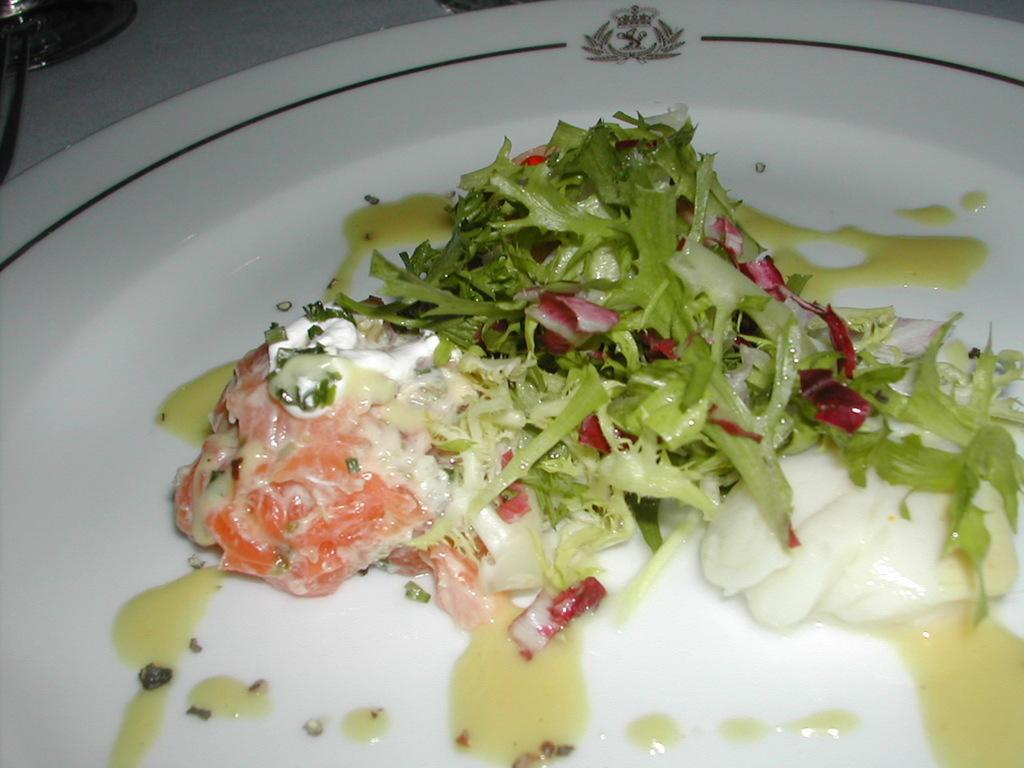What is present on the plate in the image? There is a food item on the plate. Can you describe the food item on the plate? There is a salad on the plate. What type of porter is serving the salad in the image? There is no porter present in the image, and the salad is not being served by anyone. Is this a birthday celebration, as indicated by the presence of a cake in the image? There is no cake present in the image, and no indication of a birthday celebration. 